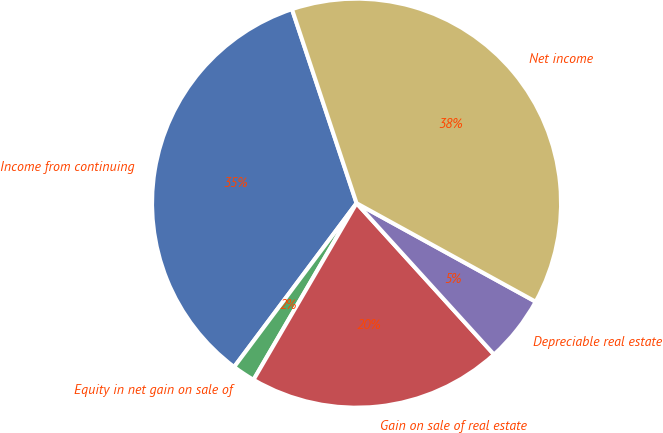Convert chart. <chart><loc_0><loc_0><loc_500><loc_500><pie_chart><fcel>Income from continuing<fcel>Equity in net gain on sale of<fcel>Gain on sale of real estate<fcel>Depreciable real estate<fcel>Net income<nl><fcel>34.67%<fcel>1.81%<fcel>20.14%<fcel>5.26%<fcel>38.12%<nl></chart> 